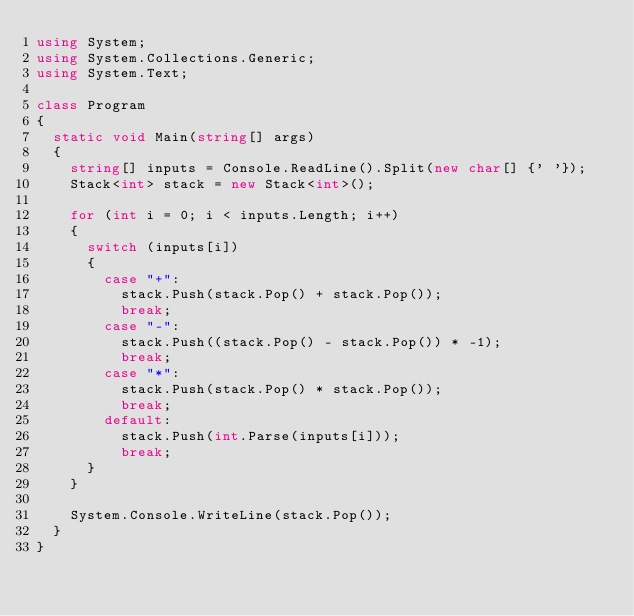Convert code to text. <code><loc_0><loc_0><loc_500><loc_500><_C#_>using System;
using System.Collections.Generic;
using System.Text;

class Program
{
	static void Main(string[] args)
	{
		string[] inputs = Console.ReadLine().Split(new char[] {' '});
		Stack<int> stack = new Stack<int>();

		for (int i = 0; i < inputs.Length; i++)
		{
			switch (inputs[i])
			{
				case "+":
					stack.Push(stack.Pop() + stack.Pop());
					break;
				case "-":
					stack.Push((stack.Pop() - stack.Pop()) * -1);
					break;
				case "*":
					stack.Push(stack.Pop() * stack.Pop());
					break;
				default:
					stack.Push(int.Parse(inputs[i]));
					break;
			}
		}

		System.Console.WriteLine(stack.Pop());
	}
}

</code> 